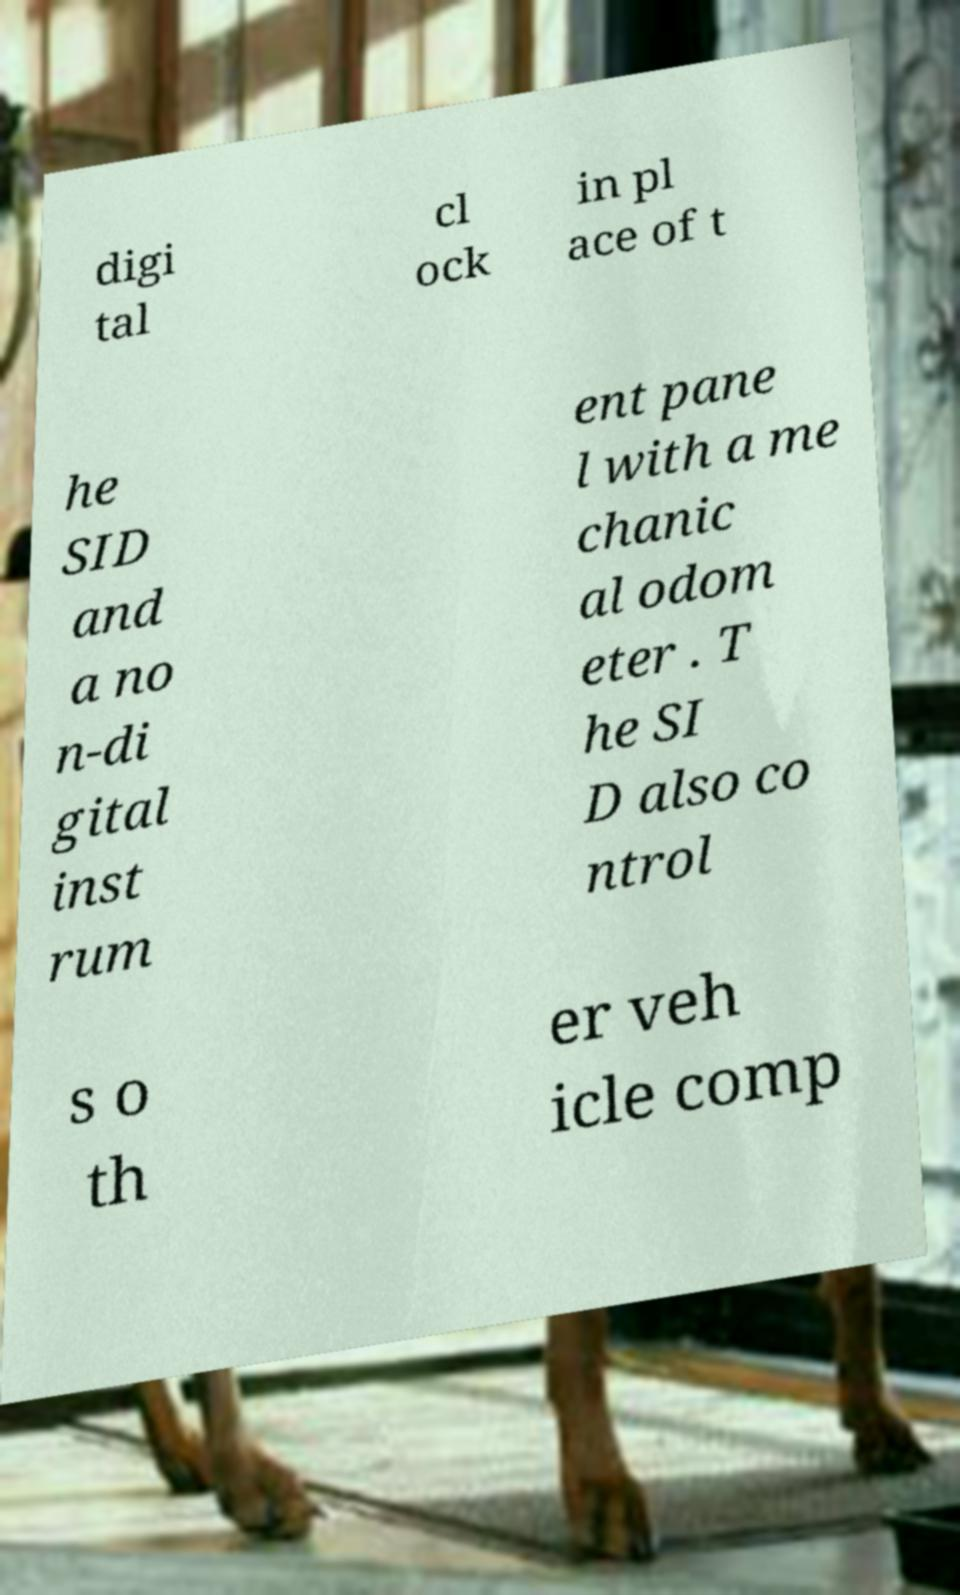For documentation purposes, I need the text within this image transcribed. Could you provide that? digi tal cl ock in pl ace of t he SID and a no n-di gital inst rum ent pane l with a me chanic al odom eter . T he SI D also co ntrol s o th er veh icle comp 